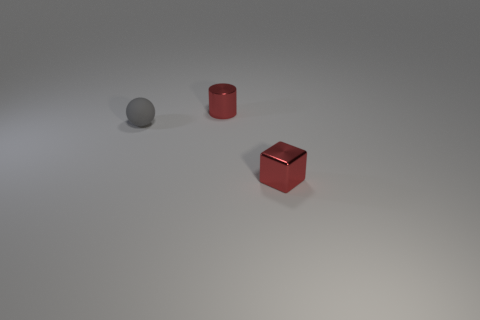Add 3 green matte balls. How many objects exist? 6 Add 1 large shiny blocks. How many large shiny blocks exist? 1 Subtract 1 red cylinders. How many objects are left? 2 Subtract all blocks. How many objects are left? 2 Subtract all green cubes. How many yellow spheres are left? 0 Subtract all gray things. Subtract all tiny rubber balls. How many objects are left? 1 Add 1 tiny shiny cubes. How many tiny shiny cubes are left? 2 